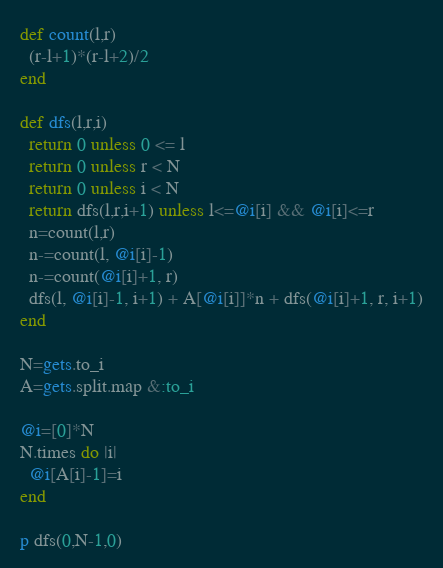Convert code to text. <code><loc_0><loc_0><loc_500><loc_500><_Ruby_>def count(l,r)
  (r-l+1)*(r-l+2)/2
end

def dfs(l,r,i)
  return 0 unless 0 <= l
  return 0 unless r < N
  return 0 unless i < N
  return dfs(l,r,i+1) unless l<=@i[i] && @i[i]<=r
  n=count(l,r)
  n-=count(l, @i[i]-1)
  n-=count(@i[i]+1, r)
  dfs(l, @i[i]-1, i+1) + A[@i[i]]*n + dfs(@i[i]+1, r, i+1)
end

N=gets.to_i
A=gets.split.map &:to_i

@i=[0]*N
N.times do |i|
  @i[A[i]-1]=i
end

p dfs(0,N-1,0)
</code> 